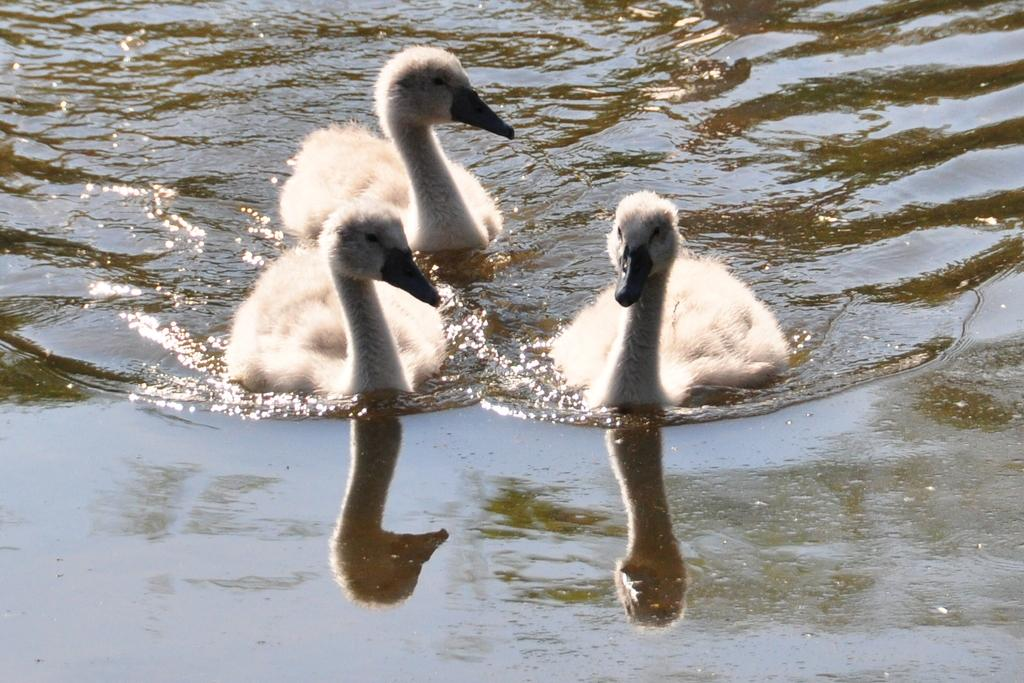How many swans are in the picture? There are three swans in the picture. What color are the swans? The swans are white in color. Where are the swans located in the picture? The swans are floating in the water. What shape is the kettle in the picture? There is no kettle present in the picture; it features three white swans floating in the water. 